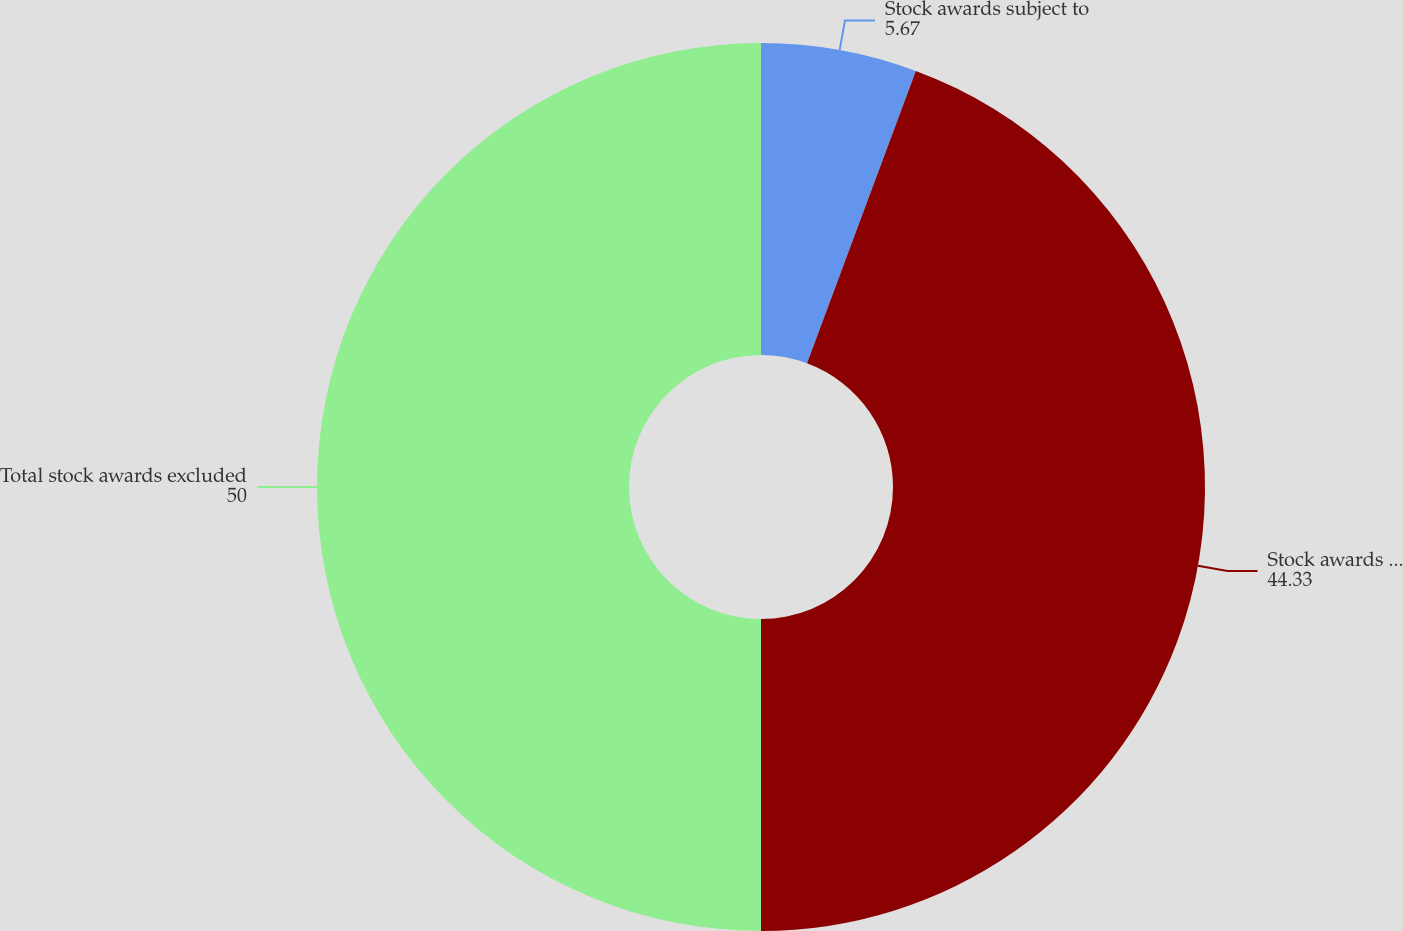Convert chart to OTSL. <chart><loc_0><loc_0><loc_500><loc_500><pie_chart><fcel>Stock awards subject to<fcel>Stock awards that were<fcel>Total stock awards excluded<nl><fcel>5.67%<fcel>44.33%<fcel>50.0%<nl></chart> 